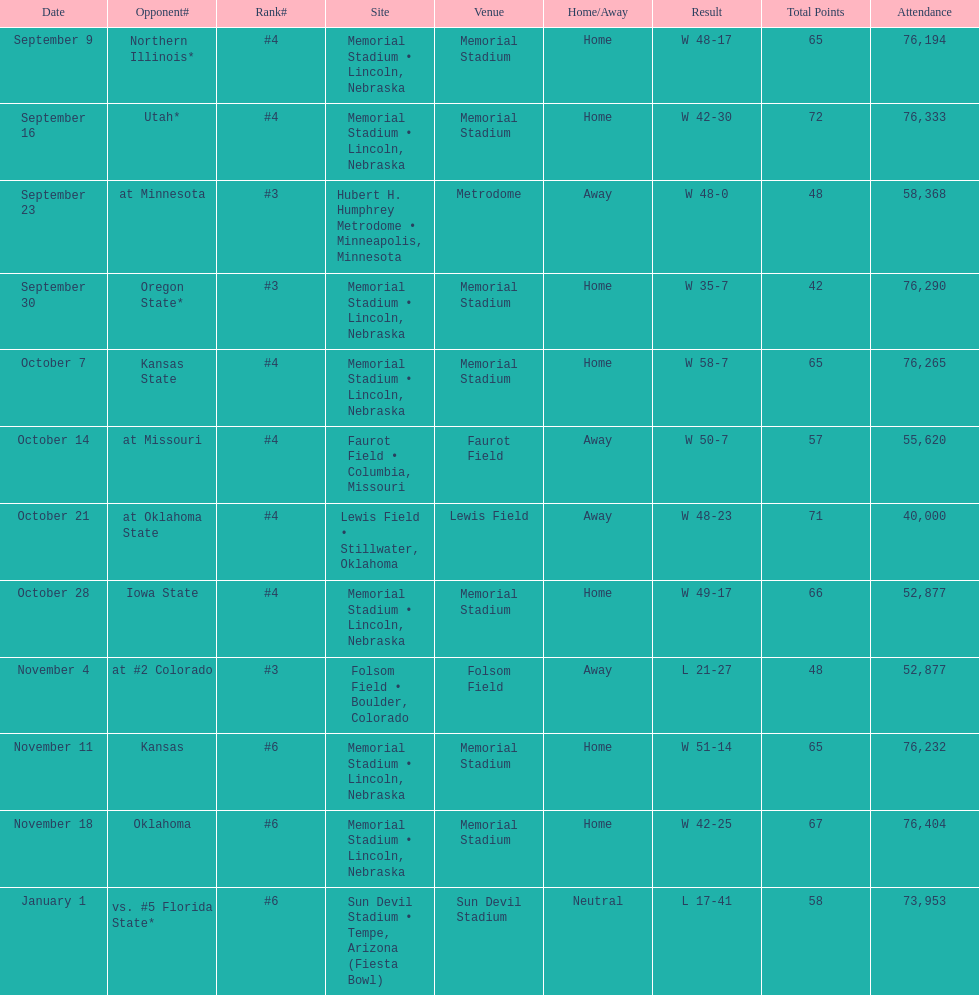What is the next site listed after lewis field? Memorial Stadium • Lincoln, Nebraska. 